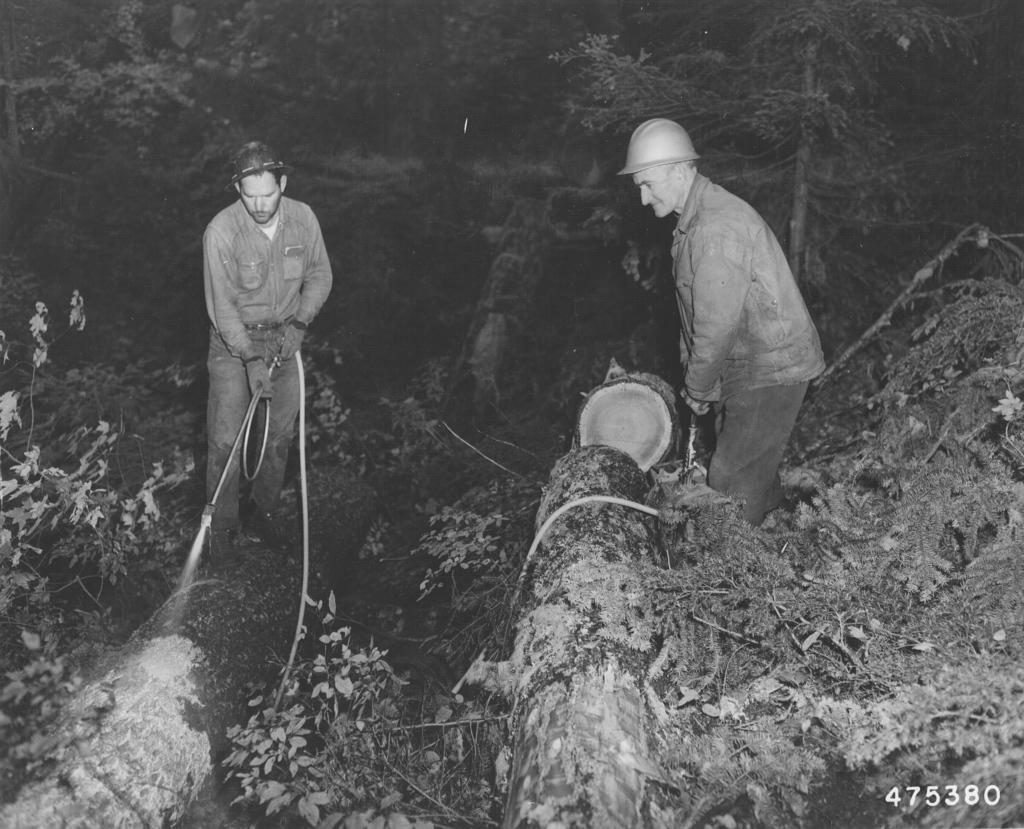How many people are in the image? There are two persons in the image. What are the persons holding in the image? The persons are holding a pipe and a tree trunk. What is the ground made of in the image? The scene takes place on grass. What can be seen in the background of the image? There are trees in the background of the image. Can you describe the lighting conditions in the image? The image may have been taken during the night, so the lighting conditions might be dark. Where might this image have been taken? The image may have been taken in a forest, given the presence of trees and grass. What is the committee discussing in the image? There is no committee present in the image, so it is not possible to determine what they might be discussing. 